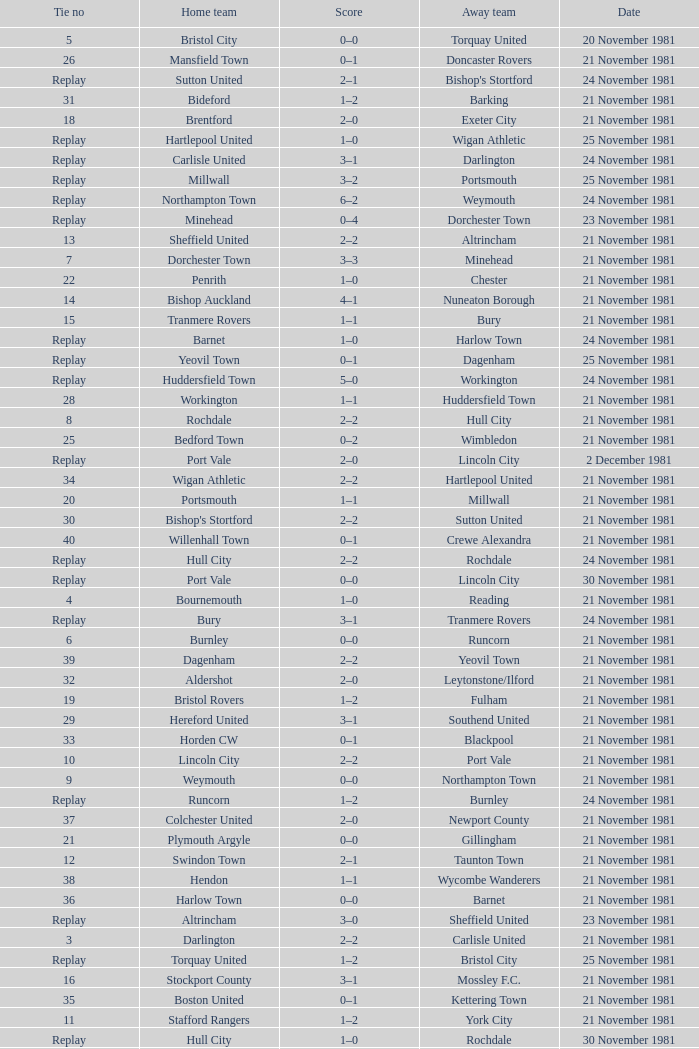What is enfield's tie number? 1.0. 